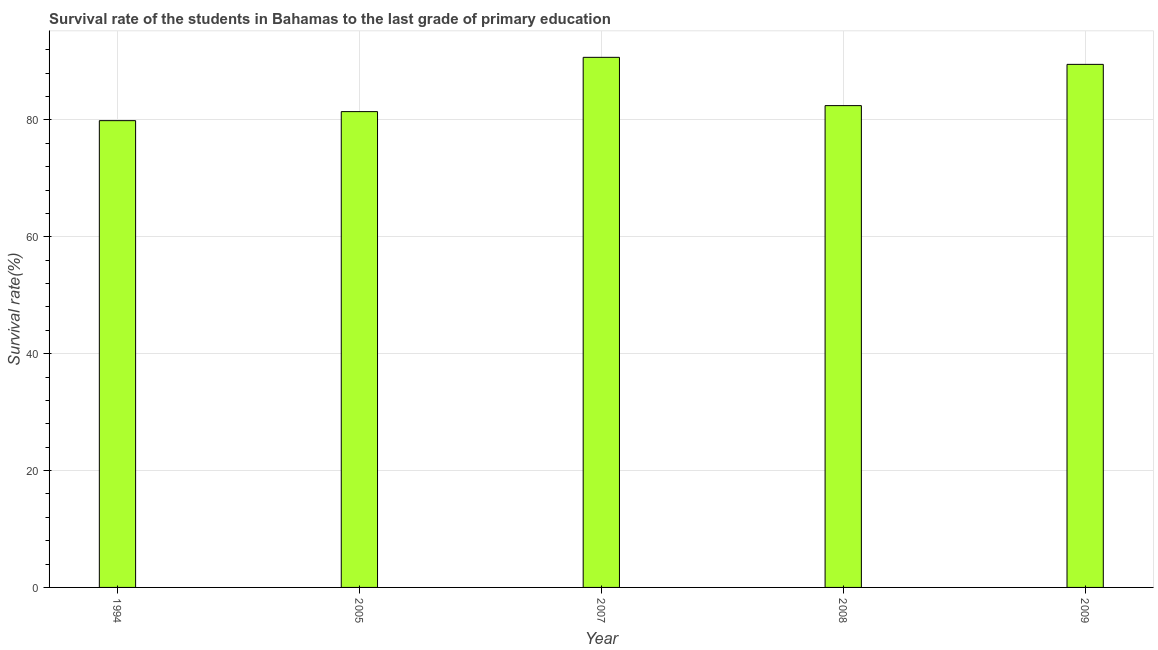Does the graph contain any zero values?
Make the answer very short. No. What is the title of the graph?
Your answer should be very brief. Survival rate of the students in Bahamas to the last grade of primary education. What is the label or title of the X-axis?
Your response must be concise. Year. What is the label or title of the Y-axis?
Ensure brevity in your answer.  Survival rate(%). What is the survival rate in primary education in 2008?
Your response must be concise. 82.44. Across all years, what is the maximum survival rate in primary education?
Your response must be concise. 90.71. Across all years, what is the minimum survival rate in primary education?
Make the answer very short. 79.87. In which year was the survival rate in primary education minimum?
Keep it short and to the point. 1994. What is the sum of the survival rate in primary education?
Give a very brief answer. 423.93. What is the difference between the survival rate in primary education in 2008 and 2009?
Offer a very short reply. -7.06. What is the average survival rate in primary education per year?
Make the answer very short. 84.79. What is the median survival rate in primary education?
Give a very brief answer. 82.44. What is the difference between the highest and the second highest survival rate in primary education?
Provide a short and direct response. 1.21. What is the difference between the highest and the lowest survival rate in primary education?
Make the answer very short. 10.83. In how many years, is the survival rate in primary education greater than the average survival rate in primary education taken over all years?
Keep it short and to the point. 2. Are all the bars in the graph horizontal?
Provide a short and direct response. No. How many years are there in the graph?
Offer a terse response. 5. What is the difference between two consecutive major ticks on the Y-axis?
Provide a succinct answer. 20. What is the Survival rate(%) in 1994?
Ensure brevity in your answer.  79.87. What is the Survival rate(%) in 2005?
Make the answer very short. 81.42. What is the Survival rate(%) of 2007?
Provide a succinct answer. 90.71. What is the Survival rate(%) in 2008?
Offer a terse response. 82.44. What is the Survival rate(%) in 2009?
Ensure brevity in your answer.  89.5. What is the difference between the Survival rate(%) in 1994 and 2005?
Your answer should be compact. -1.54. What is the difference between the Survival rate(%) in 1994 and 2007?
Your answer should be very brief. -10.83. What is the difference between the Survival rate(%) in 1994 and 2008?
Offer a very short reply. -2.57. What is the difference between the Survival rate(%) in 1994 and 2009?
Your response must be concise. -9.63. What is the difference between the Survival rate(%) in 2005 and 2007?
Make the answer very short. -9.29. What is the difference between the Survival rate(%) in 2005 and 2008?
Keep it short and to the point. -1.03. What is the difference between the Survival rate(%) in 2005 and 2009?
Offer a terse response. -8.08. What is the difference between the Survival rate(%) in 2007 and 2008?
Your answer should be compact. 8.26. What is the difference between the Survival rate(%) in 2007 and 2009?
Provide a succinct answer. 1.21. What is the difference between the Survival rate(%) in 2008 and 2009?
Provide a short and direct response. -7.06. What is the ratio of the Survival rate(%) in 1994 to that in 2007?
Your answer should be very brief. 0.88. What is the ratio of the Survival rate(%) in 1994 to that in 2008?
Provide a short and direct response. 0.97. What is the ratio of the Survival rate(%) in 1994 to that in 2009?
Offer a terse response. 0.89. What is the ratio of the Survival rate(%) in 2005 to that in 2007?
Make the answer very short. 0.9. What is the ratio of the Survival rate(%) in 2005 to that in 2009?
Offer a terse response. 0.91. What is the ratio of the Survival rate(%) in 2007 to that in 2008?
Give a very brief answer. 1.1. What is the ratio of the Survival rate(%) in 2007 to that in 2009?
Your answer should be very brief. 1.01. What is the ratio of the Survival rate(%) in 2008 to that in 2009?
Provide a succinct answer. 0.92. 